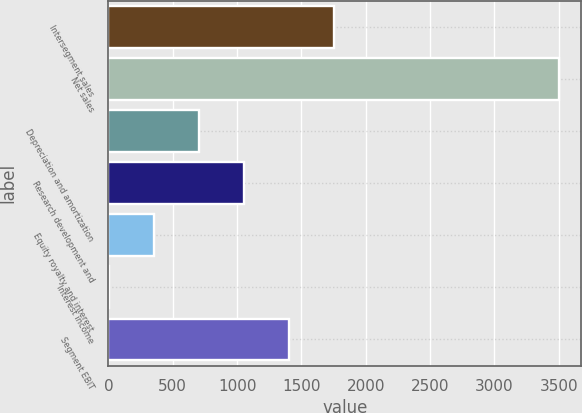Convert chart to OTSL. <chart><loc_0><loc_0><loc_500><loc_500><bar_chart><fcel>Intersegment sales<fcel>Net sales<fcel>Depreciation and amortization<fcel>Research development and<fcel>Equity royalty and interest<fcel>Interest income<fcel>Segment EBIT<nl><fcel>1751.5<fcel>3500<fcel>702.4<fcel>1052.1<fcel>352.7<fcel>3<fcel>1401.8<nl></chart> 